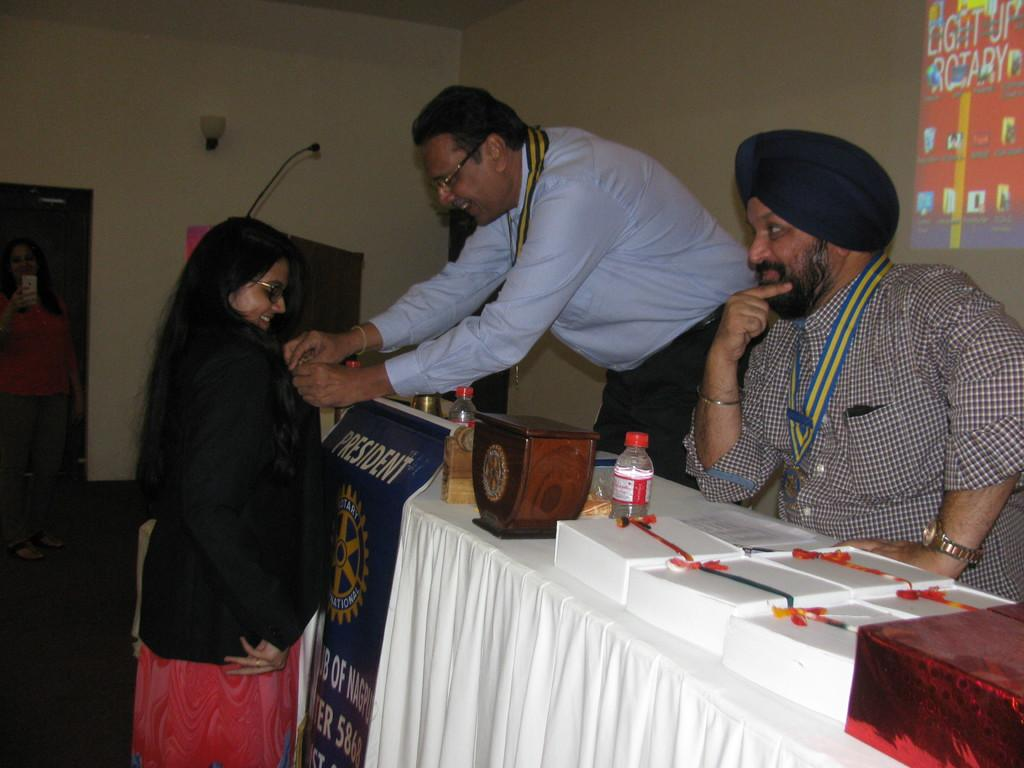<image>
Offer a succinct explanation of the picture presented. People sitting behind a table with a sign that says President. 